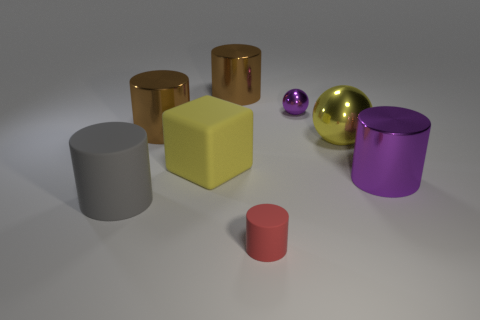There is a purple thing that is behind the purple shiny cylinder; what is its size?
Provide a succinct answer. Small. Is the size of the gray cylinder the same as the red cylinder?
Your response must be concise. No. What number of yellow things are both right of the red object and to the left of the red matte cylinder?
Ensure brevity in your answer.  0. What number of purple things are either metallic spheres or shiny things?
Offer a terse response. 2. How many matte things are either small objects or brown objects?
Make the answer very short. 1. Are there any gray matte things?
Provide a succinct answer. Yes. Is the shape of the yellow metallic thing the same as the small metallic object?
Ensure brevity in your answer.  Yes. What number of red rubber cylinders are behind the brown metal cylinder that is behind the small thing that is to the right of the small red cylinder?
Your response must be concise. 0. There is a large cylinder that is both in front of the large sphere and right of the gray cylinder; what material is it made of?
Make the answer very short. Metal. There is a large shiny thing that is both behind the cube and on the right side of the small red object; what color is it?
Your answer should be very brief. Yellow. 